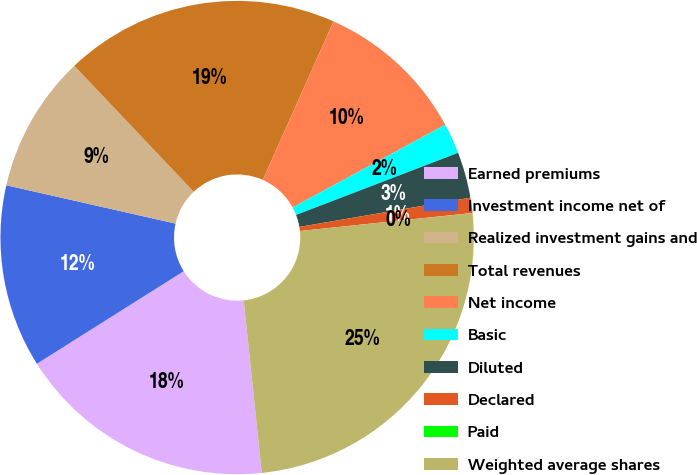Convert chart to OTSL. <chart><loc_0><loc_0><loc_500><loc_500><pie_chart><fcel>Earned premiums<fcel>Investment income net of<fcel>Realized investment gains and<fcel>Total revenues<fcel>Net income<fcel>Basic<fcel>Diluted<fcel>Declared<fcel>Paid<fcel>Weighted average shares<nl><fcel>17.71%<fcel>12.5%<fcel>9.38%<fcel>18.75%<fcel>10.42%<fcel>2.08%<fcel>3.13%<fcel>1.04%<fcel>0.0%<fcel>25.0%<nl></chart> 